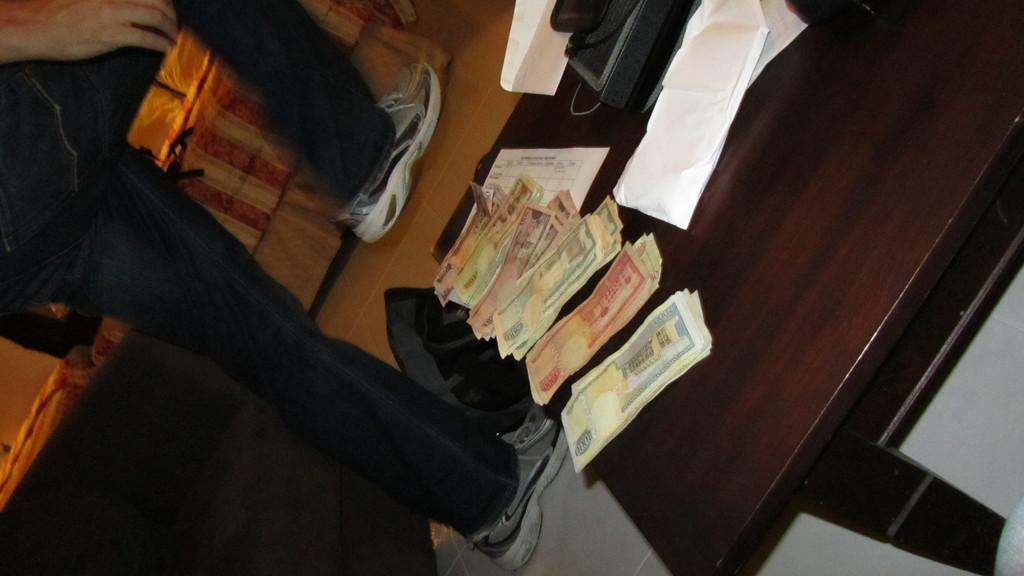Who is present in the image? There is a man in the image. What is the man doing in the image? The man is walking. What is located beside the man? There is a table beside the man. What items can be seen on the table? There is money and a telephone on the table. What type of lumber is being used to construct the hospital in the image? There is no hospital or lumber present in the image. 